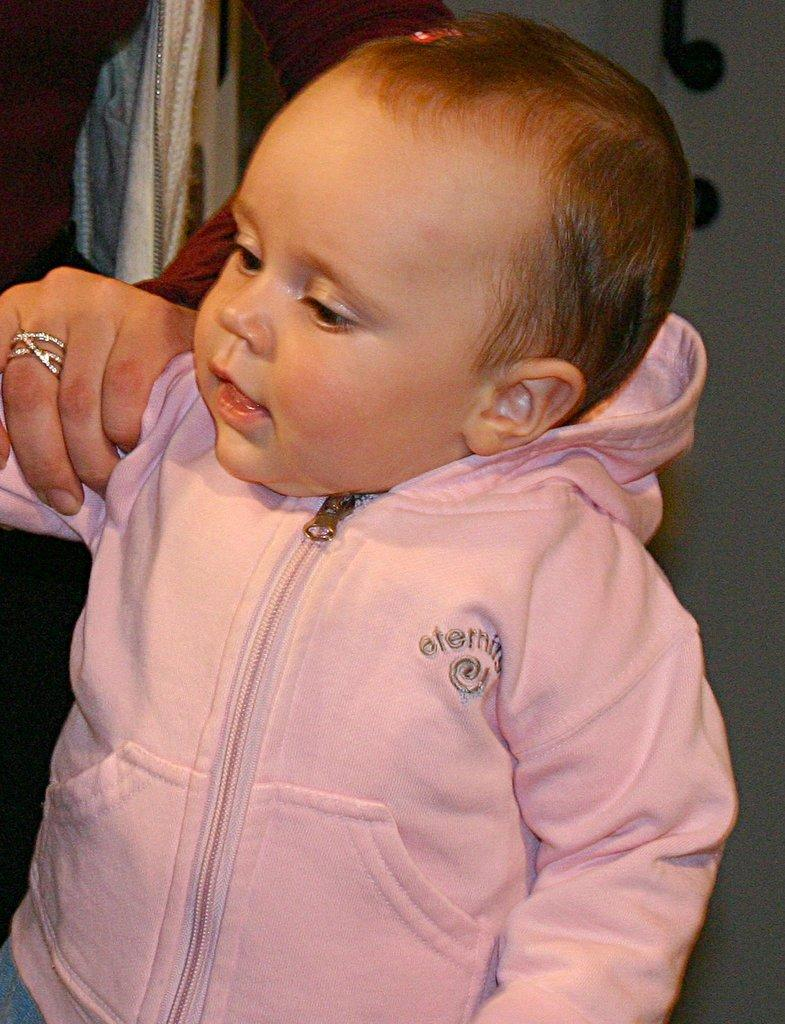What is the main subject of the image? There is a small baby in the image. Who is interacting with the baby? A woman is holding the baby's hand. What is the baby wearing? The baby is wearing a pink jacket. What type of cloud can be seen in the image? There is no cloud present in the image; it features a small baby and a woman holding the baby's hand. What kind of mark is visible on the baby's forehead? There is no mark visible on the baby's forehead in the image. 